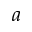Convert formula to latex. <formula><loc_0><loc_0><loc_500><loc_500>a</formula> 